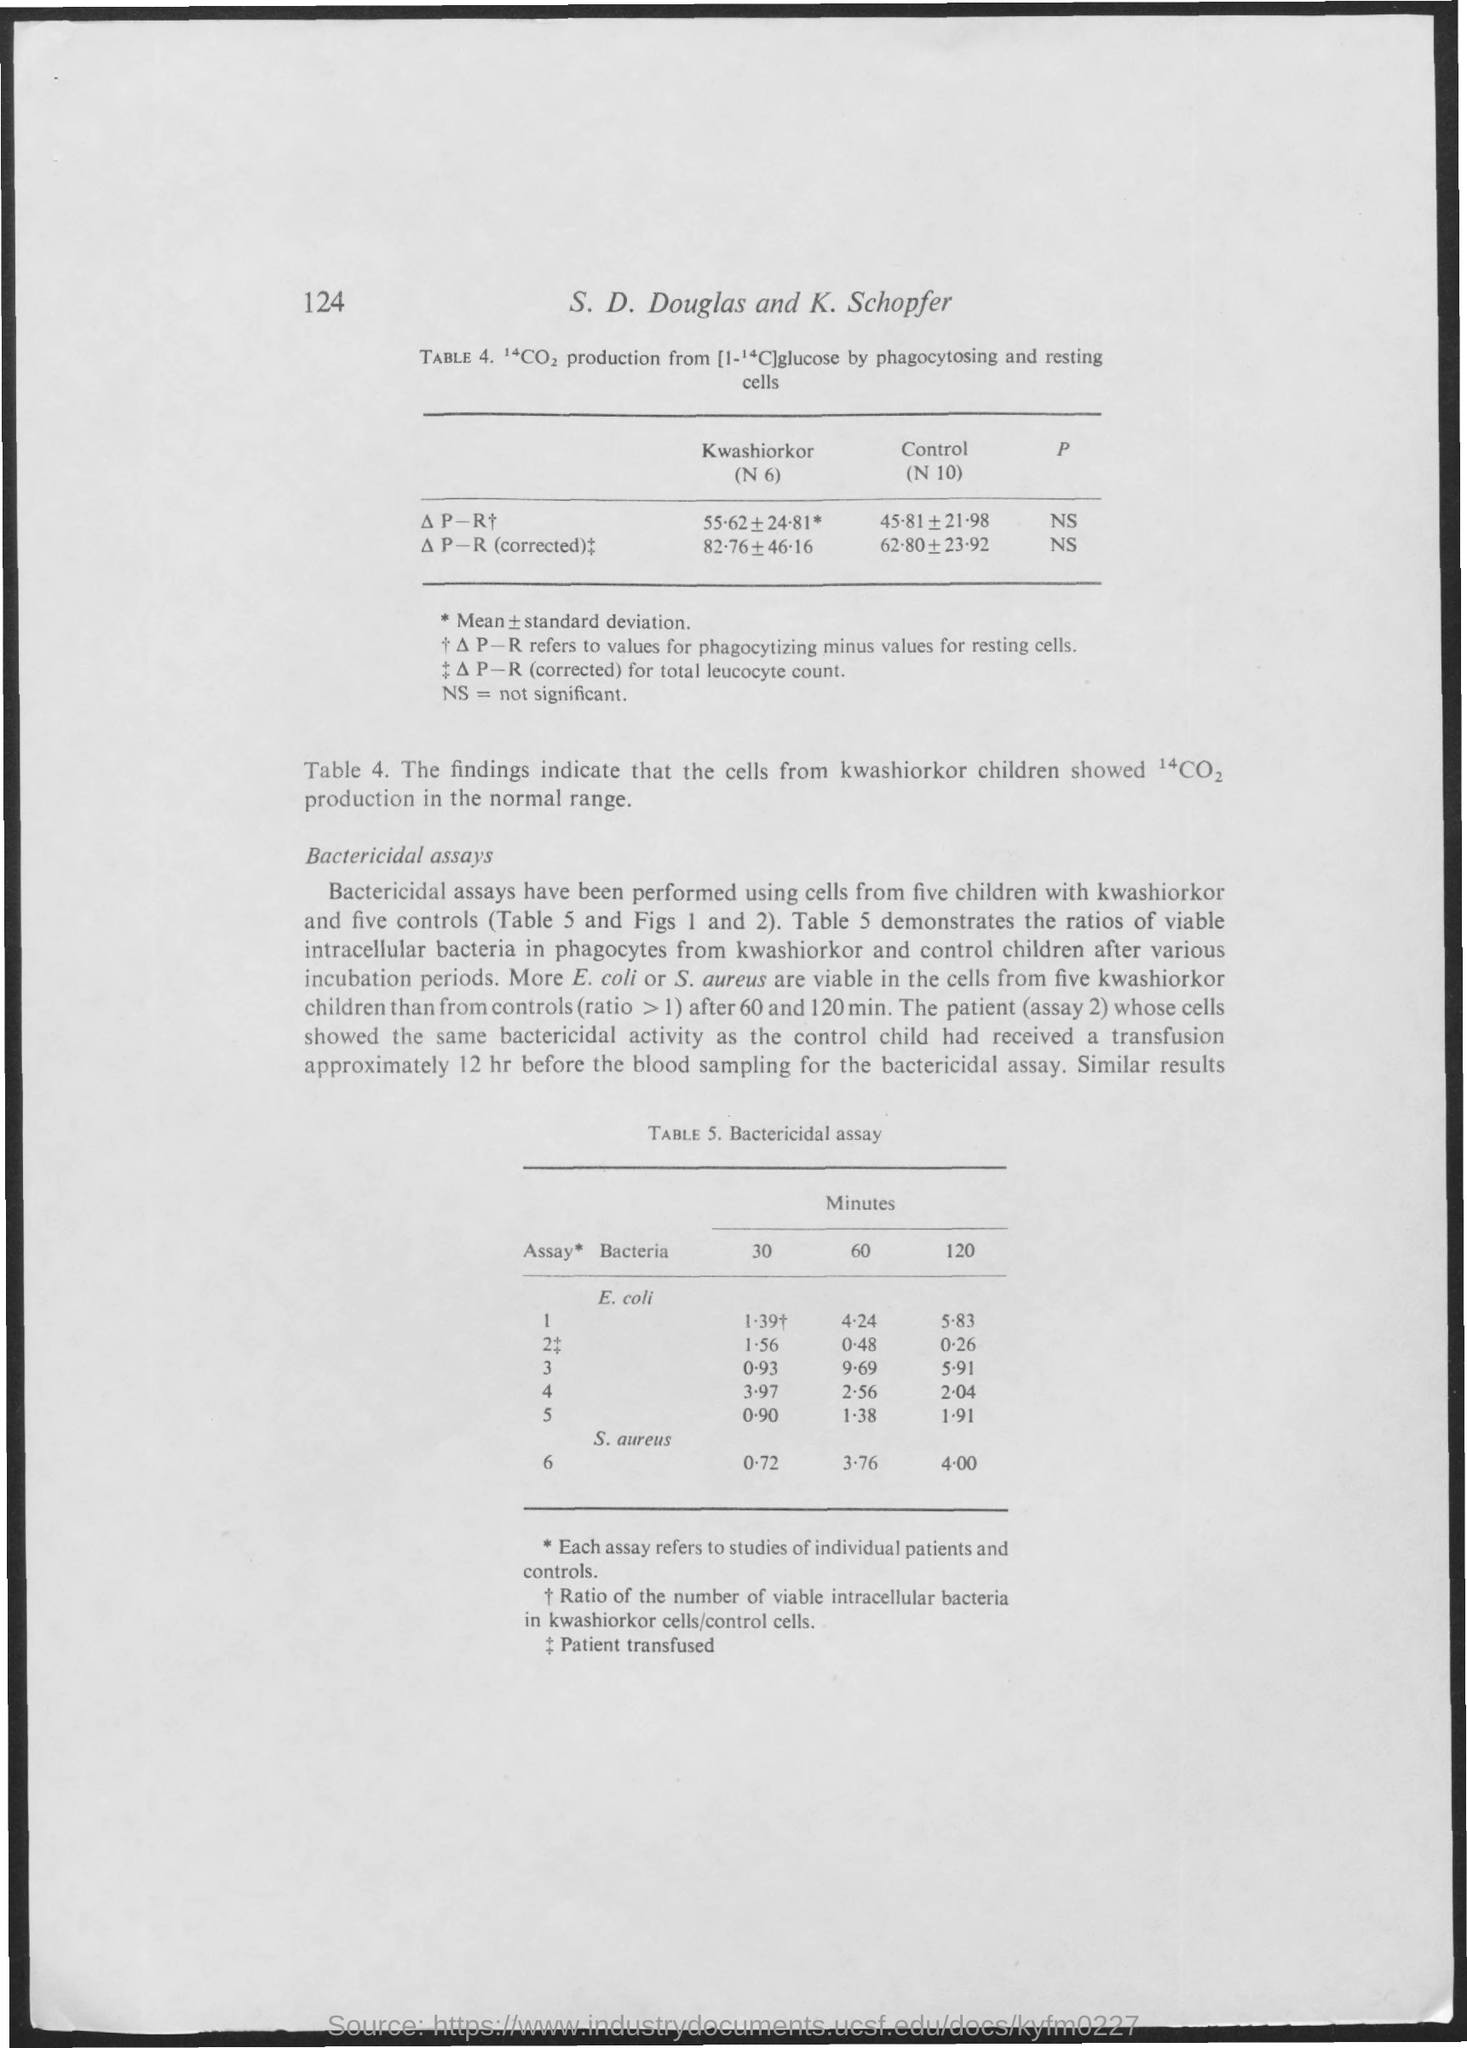Specify some key components in this picture. What is the first table number? It is Table 4. The authors of the document are S. D. Douglas and K. Schopfer. The number 124 is located at the top left corner of the document. The full form of the abbreviation "NS" is not significant. What is the second table number? It is Table 5. 